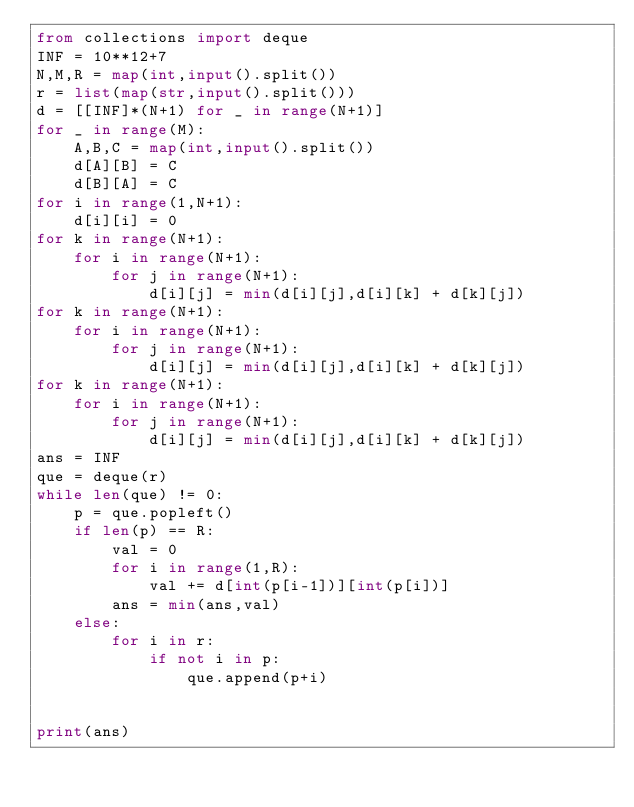Convert code to text. <code><loc_0><loc_0><loc_500><loc_500><_Python_>from collections import deque
INF = 10**12+7
N,M,R = map(int,input().split())
r = list(map(str,input().split()))
d = [[INF]*(N+1) for _ in range(N+1)]
for _ in range(M):
    A,B,C = map(int,input().split())
    d[A][B] = C
    d[B][A] = C
for i in range(1,N+1):
    d[i][i] = 0
for k in range(N+1):
    for i in range(N+1):
        for j in range(N+1):
            d[i][j] = min(d[i][j],d[i][k] + d[k][j])
for k in range(N+1):
    for i in range(N+1):
        for j in range(N+1):
            d[i][j] = min(d[i][j],d[i][k] + d[k][j])
for k in range(N+1):
    for i in range(N+1):
        for j in range(N+1):
            d[i][j] = min(d[i][j],d[i][k] + d[k][j])
ans = INF
que = deque(r)
while len(que) != 0:
    p = que.popleft()
    if len(p) == R:
        val = 0
        for i in range(1,R):
            val += d[int(p[i-1])][int(p[i])]
        ans = min(ans,val)
    else:
        for i in r:
            if not i in p:
                que.append(p+i)


print(ans)

    
</code> 